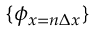Convert formula to latex. <formula><loc_0><loc_0><loc_500><loc_500>\{ \phi _ { x = n \Delta x } \}</formula> 